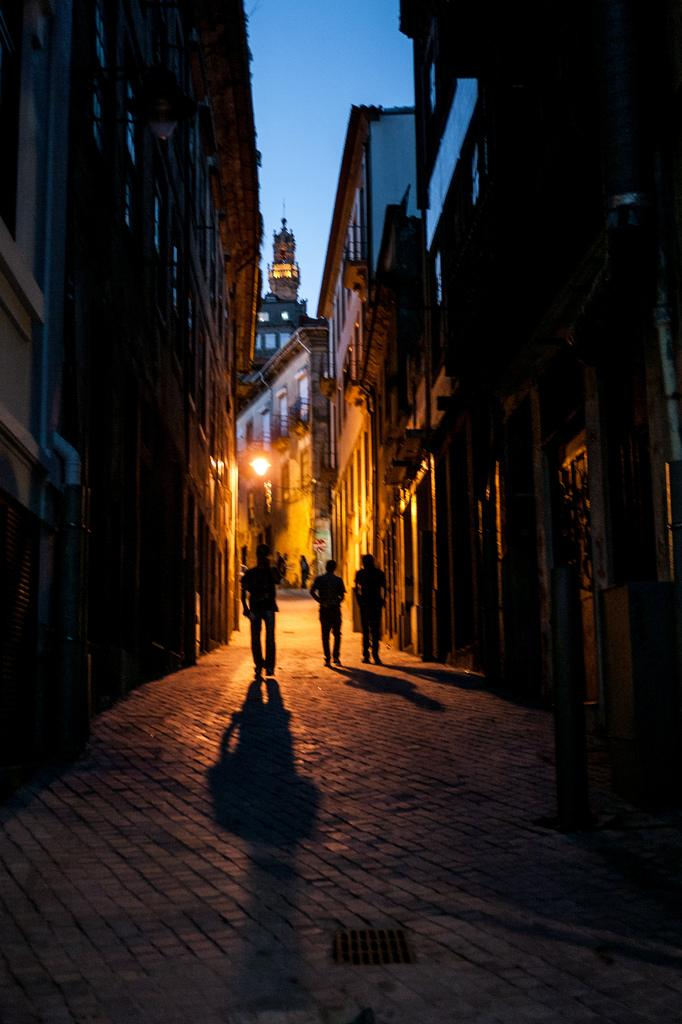What type of structures can be seen in the image? There are buildings in the image. What can be seen illuminated in the image? There are lights in the image. What architectural features are visible on the buildings? There are windows in the image. What stands out among the buildings in the image? There is a tower in the image. What are the people in the image doing? A group of people are walking on the road in the image. What is the color of the sky in the image? The sky is blue in the image. Based on the presence of lights and the blue sky, what time of day might the image have been taken? The image is likely taken during the night. Where is the toothbrush located in the image? There is no toothbrush present in the image. What type of rodents can be seen scurrying around the buildings in the image? There are no rodents, such as mice, present in the image. 